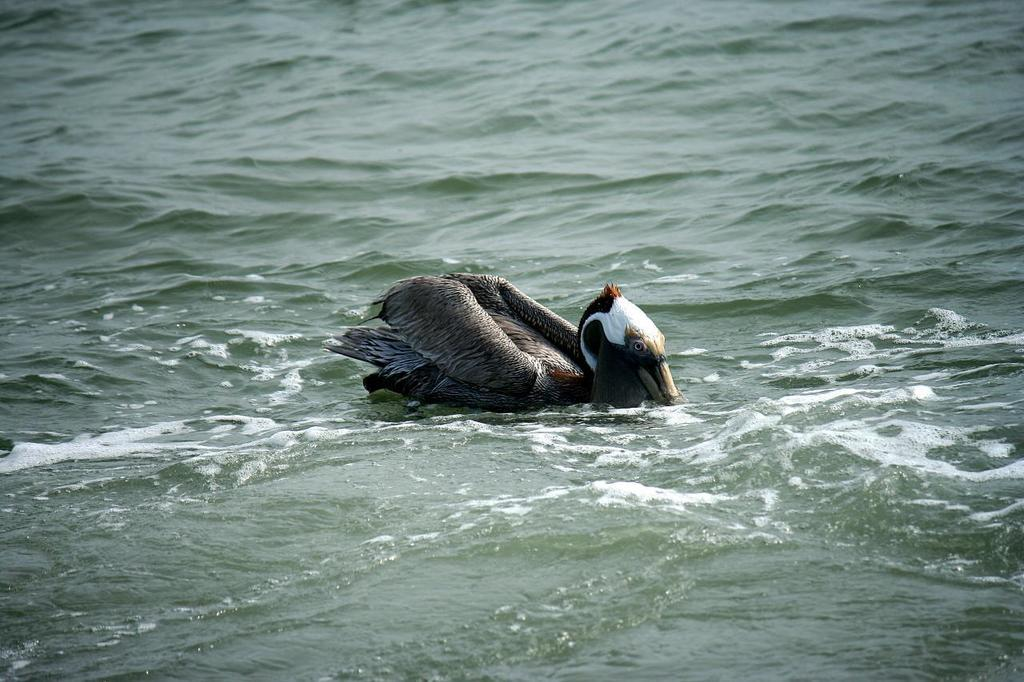What animal can be seen in the image? There is a duck in the image. What is the duck doing in the image? The duck is swimming in the water. Can you describe the environment where the duck is swimming? The water might be in a pond. What type of cork can be seen floating next to the duck in the image? There is no cork present in the image; it only features a duck swimming in the water. 